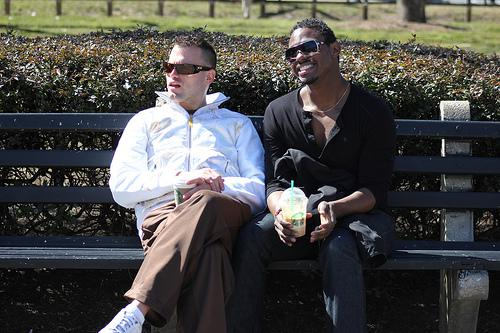Question: where was the photo taken?
Choices:
A. The courthouse.
B. The park.
C. The subway.
D. The post office.
Answer with the letter. Answer: B Question: how many sunglasses are there?
Choices:
A. Two.
B. Four.
C. Three.
D. Five.
Answer with the letter. Answer: A Question: what shirt color is to the right?
Choices:
A. Black.
B. Red.
C. Blue.
D. Green.
Answer with the letter. Answer: A Question: what shirt color is to the left?
Choices:
A. Green.
B. Black.
C. Blue.
D. White.
Answer with the letter. Answer: D Question: how many people are on the bench?
Choices:
A. Two.
B. Three.
C. Six.
D. One.
Answer with the letter. Answer: A 